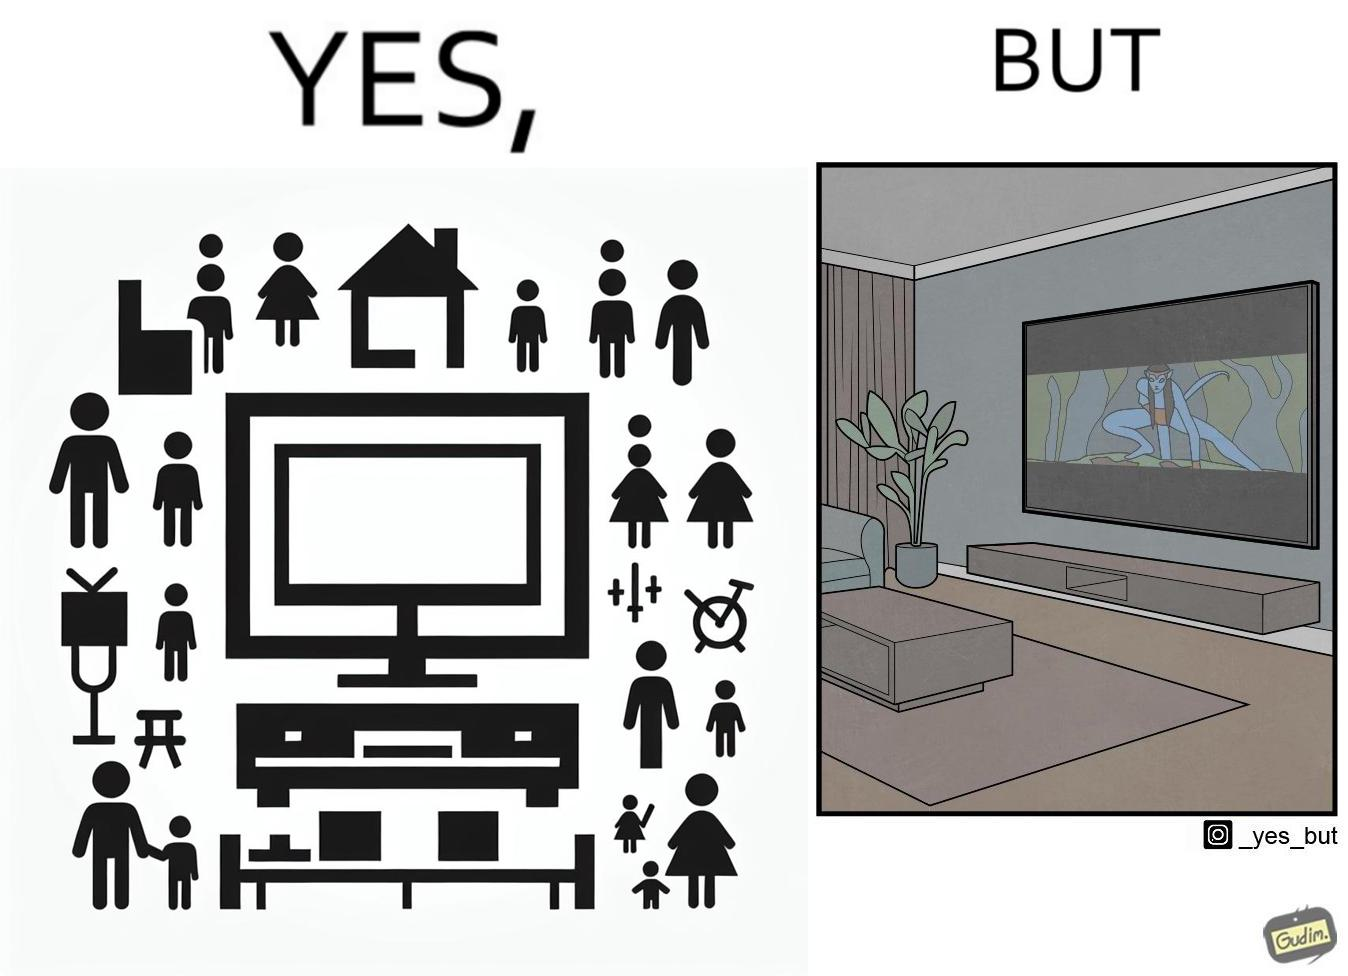Describe the satirical element in this image. The image is funny because while the room has a big TV with a big screen, the movie being played on it does not use the entire screen. 